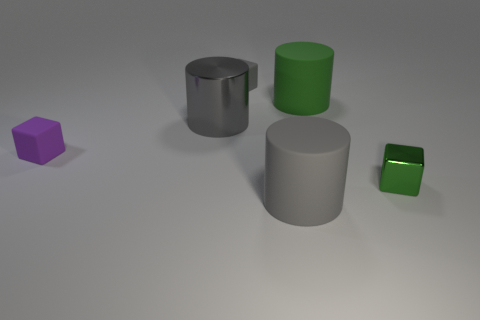What shape is the big rubber thing that is in front of the green object that is right of the large matte object behind the big gray matte cylinder?
Offer a terse response. Cylinder. There is a big gray object behind the large gray matte cylinder; what is its material?
Your answer should be very brief. Metal. How big is the rubber cube that is left of the rubber block that is behind the big object that is behind the gray shiny cylinder?
Ensure brevity in your answer.  Small. Do the purple object and the gray thing on the right side of the gray rubber block have the same size?
Offer a terse response. No. What is the color of the tiny matte block that is on the left side of the gray metallic cylinder?
Offer a very short reply. Purple. There is a big object that is the same color as the small shiny thing; what shape is it?
Provide a succinct answer. Cylinder. There is a big gray thing behind the tiny green metal block; what is its shape?
Your answer should be very brief. Cylinder. Is the material of the tiny green thing the same as the purple block?
Provide a short and direct response. No. What material is the big cylinder that is behind the purple block and right of the tiny gray object?
Offer a very short reply. Rubber. There is a green object that is the same shape as the gray metallic object; what is it made of?
Your answer should be compact. Rubber. 